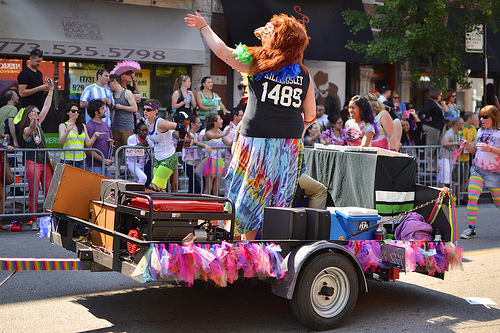<image>
Is there a man to the left of the man? Yes. From this viewpoint, the man is positioned to the left side relative to the man. Where is the man in relation to the woman? Is it behind the woman? Yes. From this viewpoint, the man is positioned behind the woman, with the woman partially or fully occluding the man. Where is the skirt in relation to the tire? Is it behind the tire? Yes. From this viewpoint, the skirt is positioned behind the tire, with the tire partially or fully occluding the skirt. 